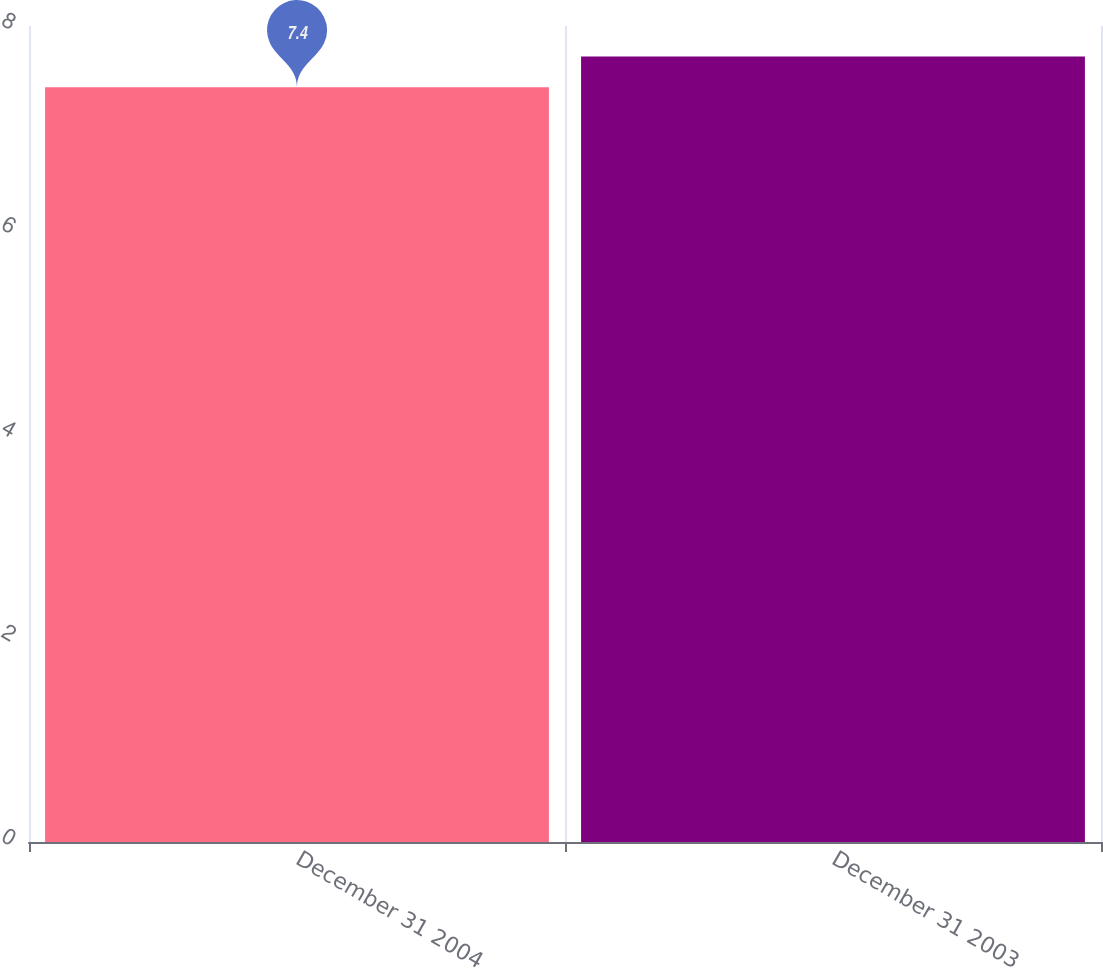Convert chart. <chart><loc_0><loc_0><loc_500><loc_500><bar_chart><fcel>December 31 2004<fcel>December 31 2003<nl><fcel>7.4<fcel>7.7<nl></chart> 